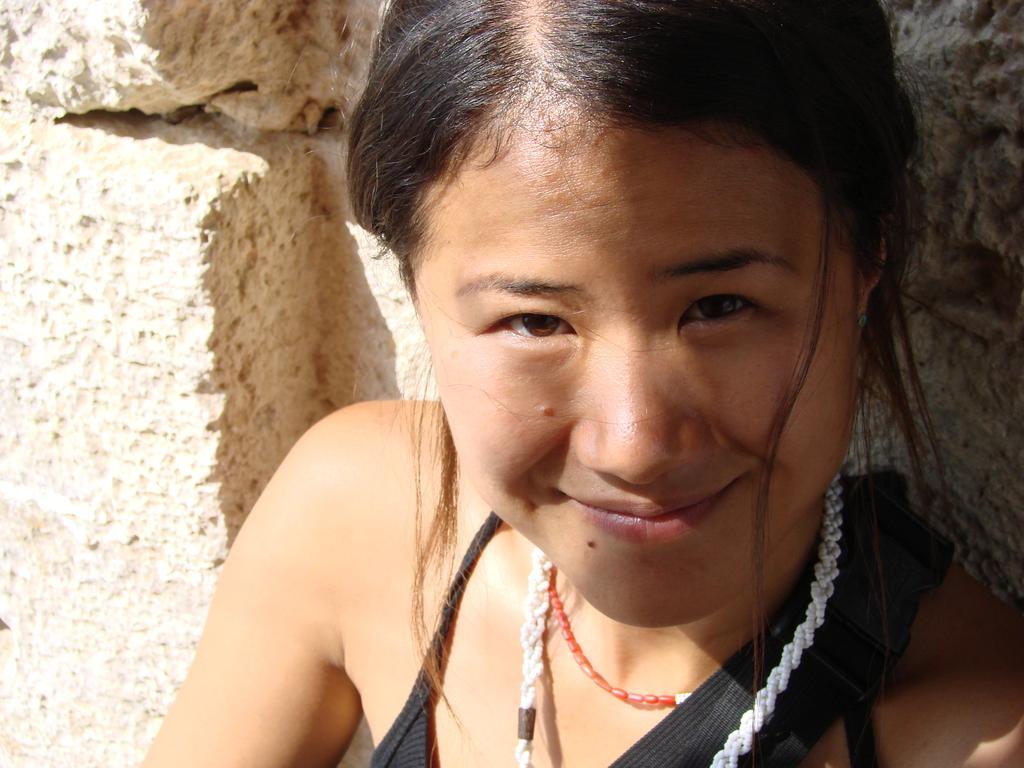How would you summarize this image in a sentence or two? In the image there is a woman in black dress and necklace smiling and behind her there is a wall. 